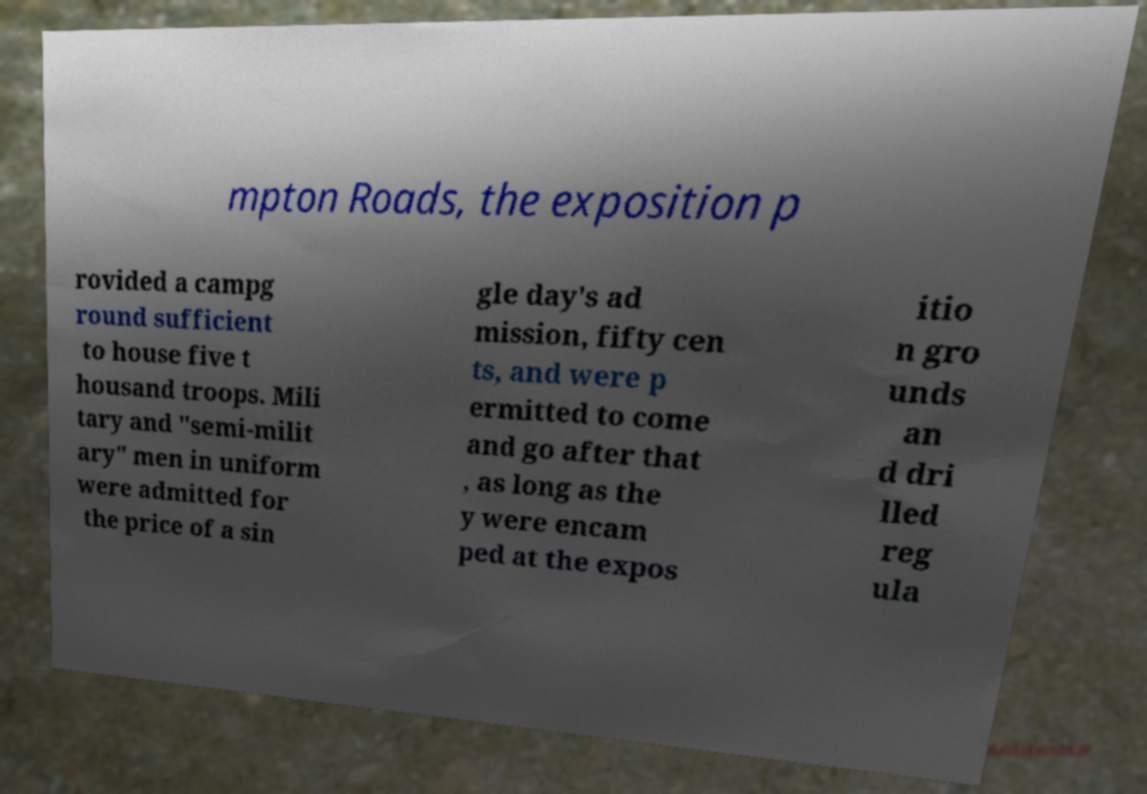Can you accurately transcribe the text from the provided image for me? mpton Roads, the exposition p rovided a campg round sufficient to house five t housand troops. Mili tary and "semi-milit ary" men in uniform were admitted for the price of a sin gle day's ad mission, fifty cen ts, and were p ermitted to come and go after that , as long as the y were encam ped at the expos itio n gro unds an d dri lled reg ula 